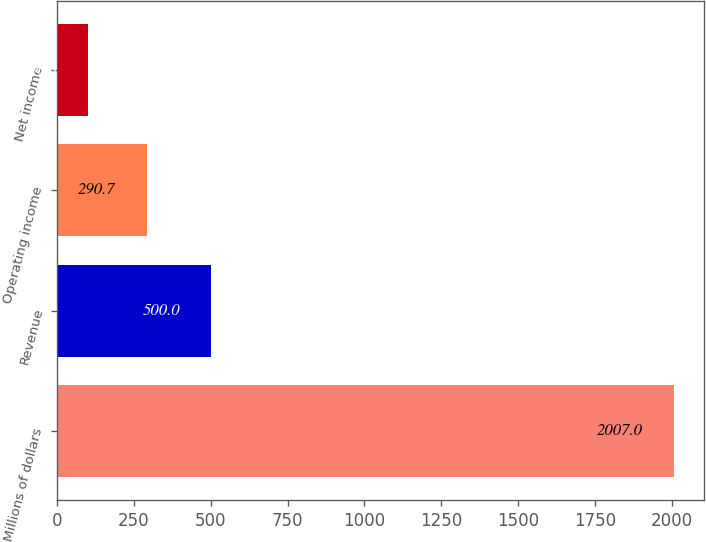Convert chart to OTSL. <chart><loc_0><loc_0><loc_500><loc_500><bar_chart><fcel>Millions of dollars<fcel>Revenue<fcel>Operating income<fcel>Net income<nl><fcel>2007<fcel>500<fcel>290.7<fcel>100<nl></chart> 